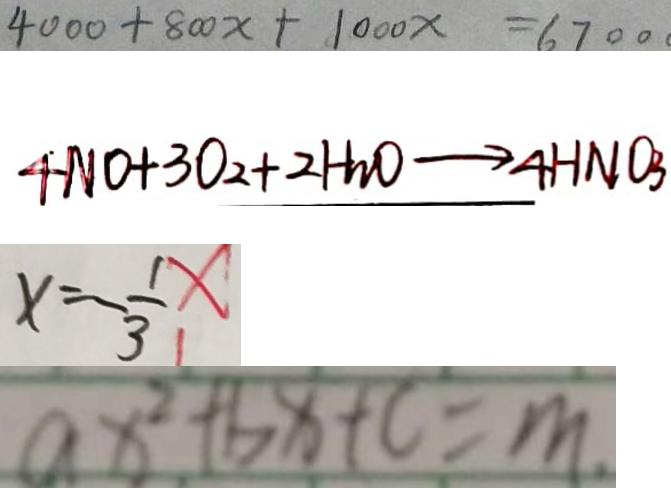<formula> <loc_0><loc_0><loc_500><loc_500>4 0 0 0 + 8 0 0 x + 1 0 0 0 x = 6 7 0 0 
 4 N O + 3 O _ { 2 } + 2 H _ { 3 } O \rightarrow 4 H N O _ { 3 } 
 x = - \frac { 1 } { 3 } 
 a x ^ { 2 } + b x + c = m .</formula> 